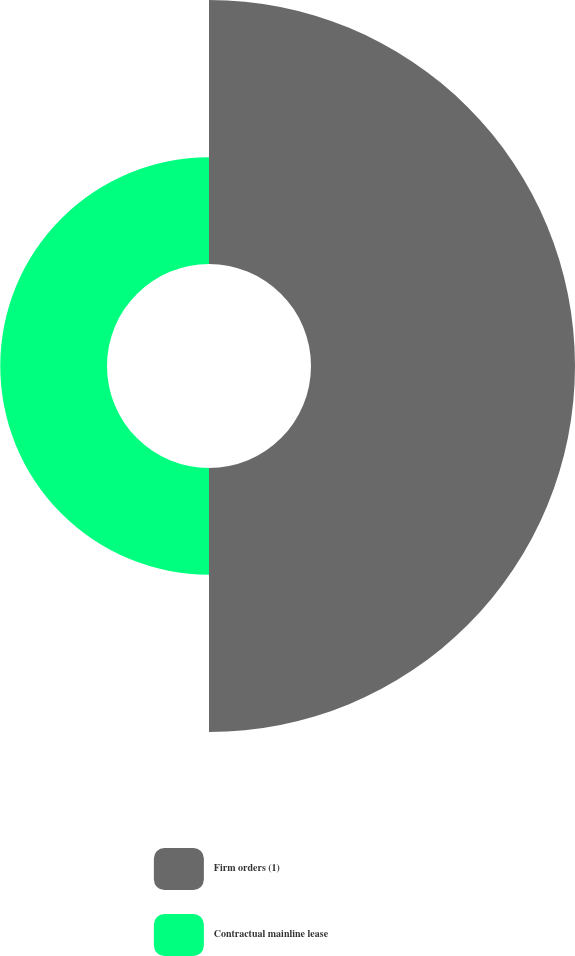Convert chart. <chart><loc_0><loc_0><loc_500><loc_500><pie_chart><fcel>Firm orders (1)<fcel>Contractual mainline lease<nl><fcel>71.21%<fcel>28.79%<nl></chart> 